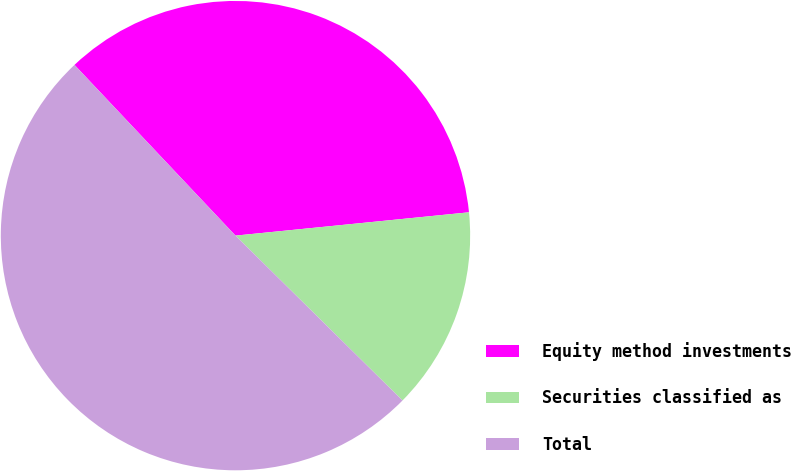Convert chart to OTSL. <chart><loc_0><loc_0><loc_500><loc_500><pie_chart><fcel>Equity method investments<fcel>Securities classified as<fcel>Total<nl><fcel>35.45%<fcel>13.98%<fcel>50.57%<nl></chart> 